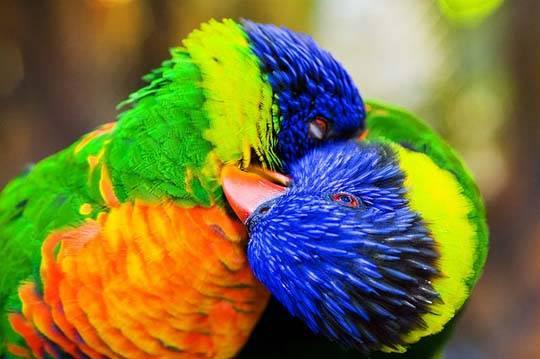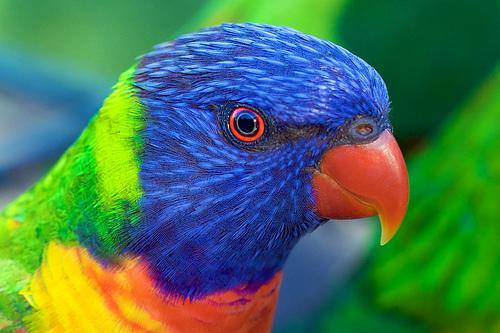The first image is the image on the left, the second image is the image on the right. For the images shown, is this caption "Exactly three parrots are seated on perches." true? Answer yes or no. No. 